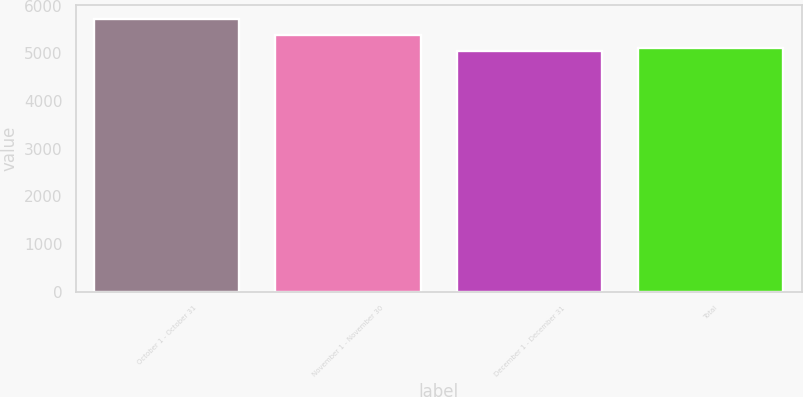Convert chart. <chart><loc_0><loc_0><loc_500><loc_500><bar_chart><fcel>October 1 - October 31<fcel>November 1 - November 30<fcel>December 1 - December 31<fcel>Total<nl><fcel>5732<fcel>5397<fcel>5055<fcel>5122.7<nl></chart> 